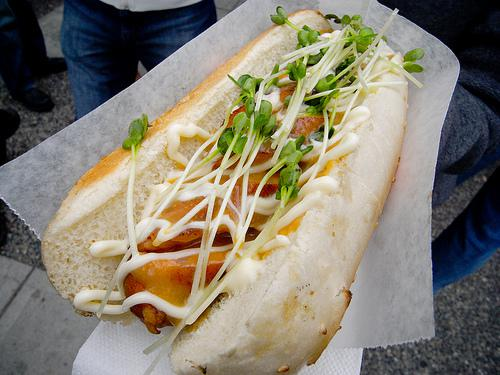Question: what is in the picture?
Choices:
A. A pizza.
B. A sandwich.
C. A hamburger.
D. A hot dog.
Answer with the letter. Answer: D Question: who is holding the hotdog?
Choices:
A. A man.
B. A woman.
C. A person.
D. A little girl.
Answer with the letter. Answer: C Question: what is under the hotdog?
Choices:
A. A plate.
B. The table.
C. A paper napkin.
D. A serving tray.
Answer with the letter. Answer: C Question: who is wearing blue jeans?
Choices:
A. Three of the men with red tops.
B. People in the background.
C. A woman with a green sweater.
D. Everyone but the man with glasses.
Answer with the letter. Answer: B Question: how is it served?
Choices:
A. On a plate.
B. On a roll.
C. On bread.
D. In a shell.
Answer with the letter. Answer: B Question: what is on the hot dog?
Choices:
A. Condiments and sprouts.
B. Ketchup.
C. Cheese.
D. Chili.
Answer with the letter. Answer: A 